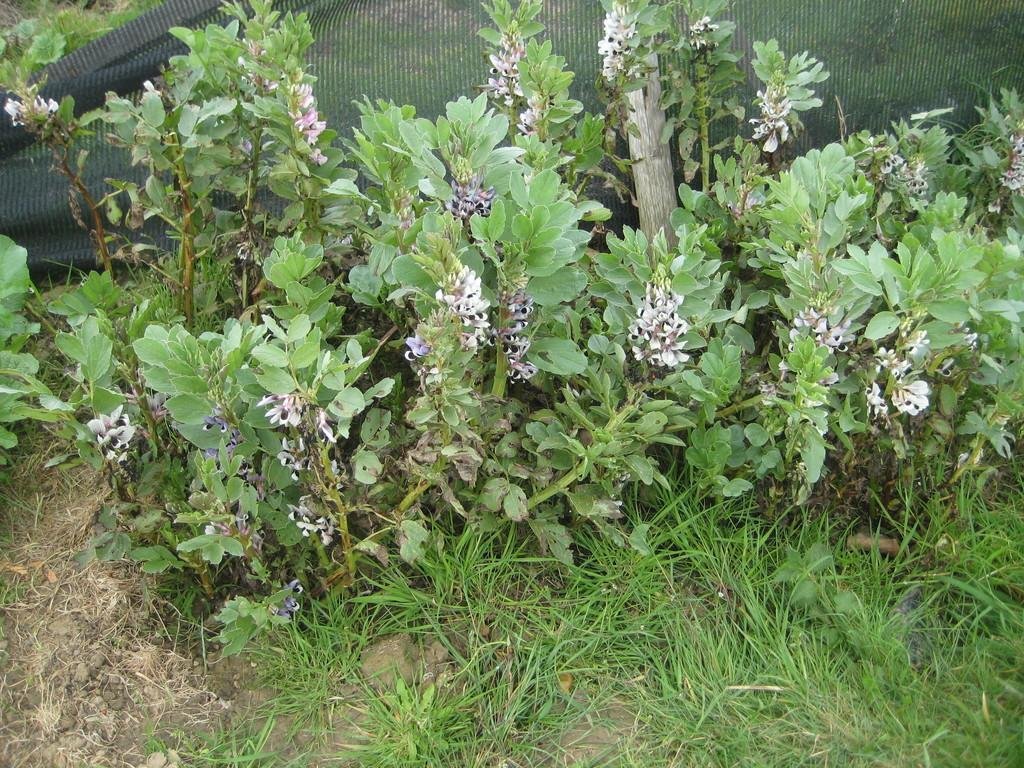What type of vegetation is visible in the image? There is grass and plants visible in the image. Can you describe the color of the cloth in the background of the image? The cloth in the background of the image is black. Are there any fairies flying around the plants in the image? There is no indication of fairies in the image; it only features grass, plants, and a black cloth in the background. What type of vegetable can be seen growing among the plants in the image? There is no vegetable visible in the image; it only features grass and plants. 